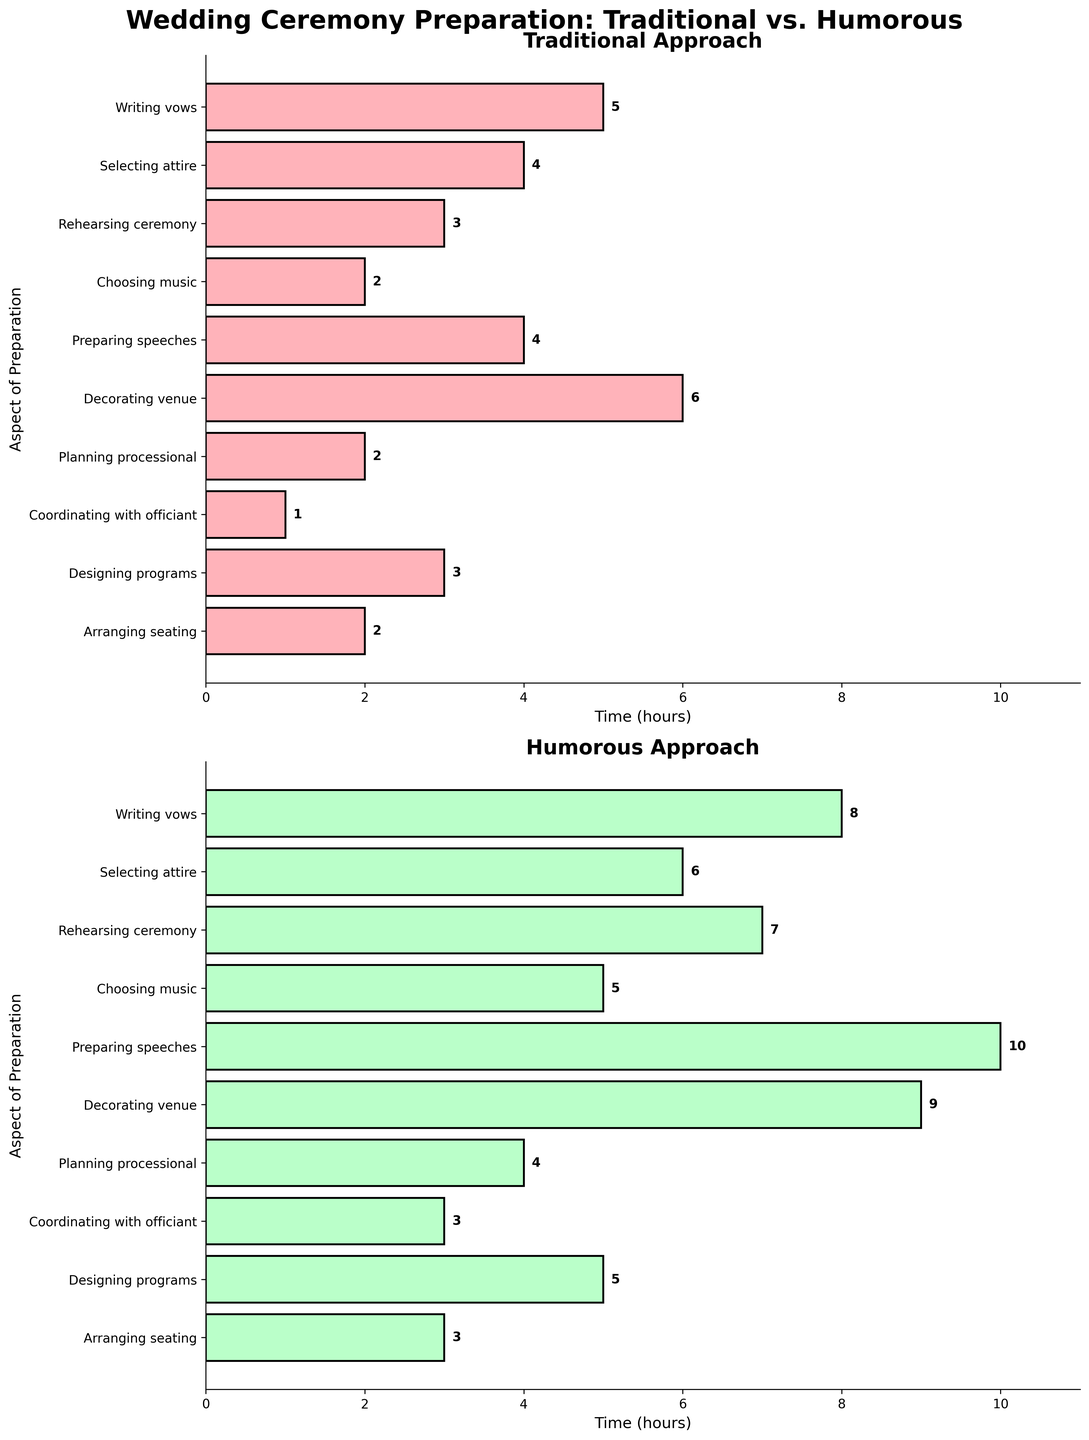What's the title of the figure? The title of the figure is located at the top and reads "Wedding Ceremony Preparation: Traditional vs. Humorous"
Answer: Wedding Ceremony Preparation: Traditional vs. Humorous How long is spent on writing vows in the humorous approach? In the Humorous Approach subplot, under the aspect "Writing vows," the bar extends to 8, indicating 8 hours.
Answer: 8 hours Which preparation aspect takes the most time in the traditional approach? In the Traditional Approach subplot, the longest bar is for "Decorating venue," which extends to 6 hours.
Answer: Decorating venue What's the difference in time spent on preparing speeches between the traditional and humorous approaches? In the Traditional subplot, preparing speeches takes 4 hours; in the Humorous subplot, it takes 10 hours. The difference is 10 - 4 = 6 hours.
Answer: 6 hours How much total time is spent selecting attire and coordinating with the officiant in both approaches combined? For the Traditional approach: Selecting attire (4) + Coordinating with officiant (1) = 5 hours. For the Humorous approach: Selecting attire (6) + Coordinating with officiant (3) = 9 hours. Combined total = 5 + 9 = 14 hours.
Answer: 14 hours Which subplot shows a greater overall time spent on each preparation aspect, the traditional or humorous approach? By visually comparing the lengths of bars in both subplots, the Humorous Approach consistently has longer bars overall than the Traditional Approach, indicating greater time spent.
Answer: Humorous approach What is the average time spent on choosing music across both approaches? Traditional time spent on choosing music is 2 hours, Humorous time is 5 hours. The average is (2 + 5) / 2 = 3.5 hours.
Answer: 3.5 hours For the aspect of rehearsing the ceremony, how many hours more are spent in the humorous approach compared to the traditional one? The humorous approach spends 7 hours on rehearsing ceremony, while the traditional one spends 3 hours. The difference is 7 - 3 = 4 hours.
Answer: 4 hours Are there any preparation aspects where the time spent is equal in both approaches? By comparing each aspect's bars in both subplots, there are no aspects with equal time spent across both approaches; times differ for every aspect.
Answer: No In terms of planning the processional, how does the humorous approach compare to the traditional? In the humorous approach, planning the processional takes 4 hours, while in the traditional approach, it takes 2 hours. The humorous approach takes twice as long.
Answer: Twice as long 